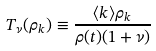Convert formula to latex. <formula><loc_0><loc_0><loc_500><loc_500>T _ { \nu } ( \rho _ { k } ) \equiv \frac { \langle k \rangle \rho _ { k } } { \rho ( t ) ( 1 + \nu ) }</formula> 